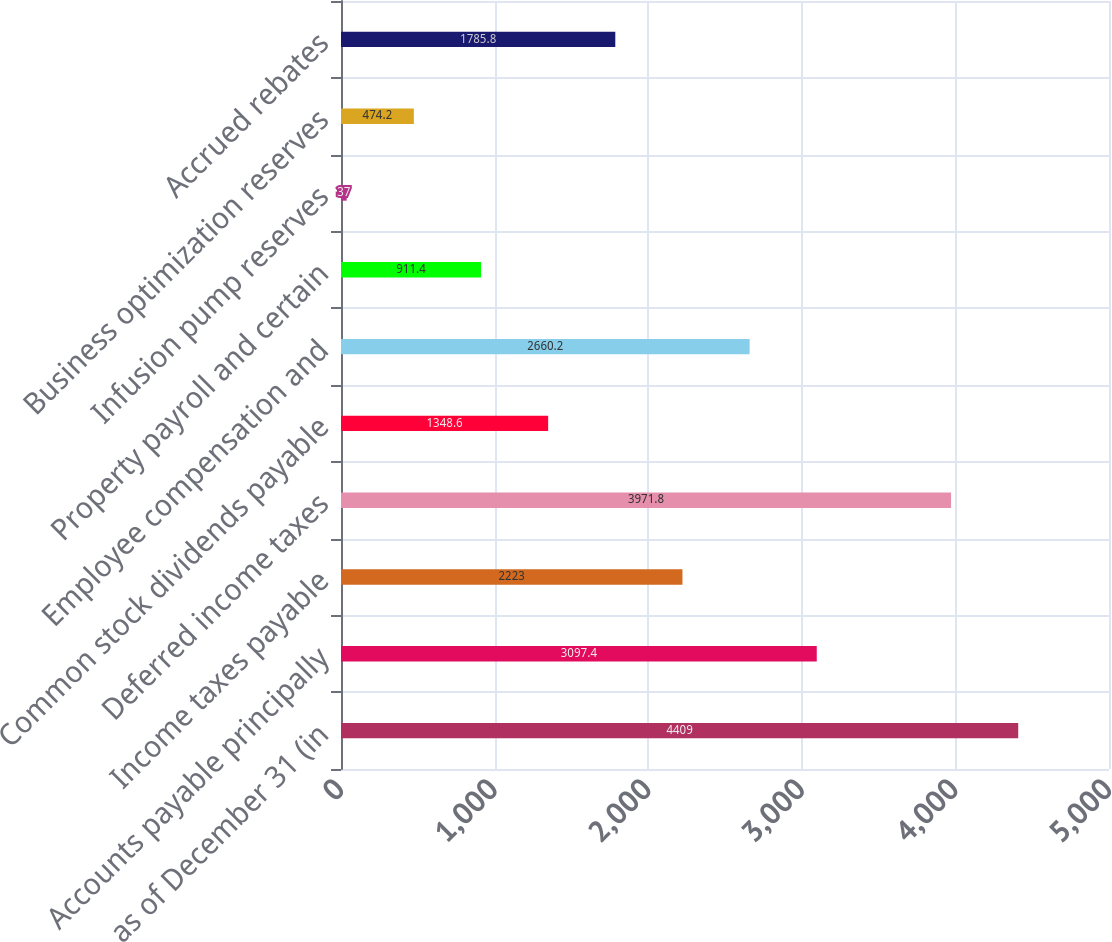<chart> <loc_0><loc_0><loc_500><loc_500><bar_chart><fcel>as of December 31 (in<fcel>Accounts payable principally<fcel>Income taxes payable<fcel>Deferred income taxes<fcel>Common stock dividends payable<fcel>Employee compensation and<fcel>Property payroll and certain<fcel>Infusion pump reserves<fcel>Business optimization reserves<fcel>Accrued rebates<nl><fcel>4409<fcel>3097.4<fcel>2223<fcel>3971.8<fcel>1348.6<fcel>2660.2<fcel>911.4<fcel>37<fcel>474.2<fcel>1785.8<nl></chart> 